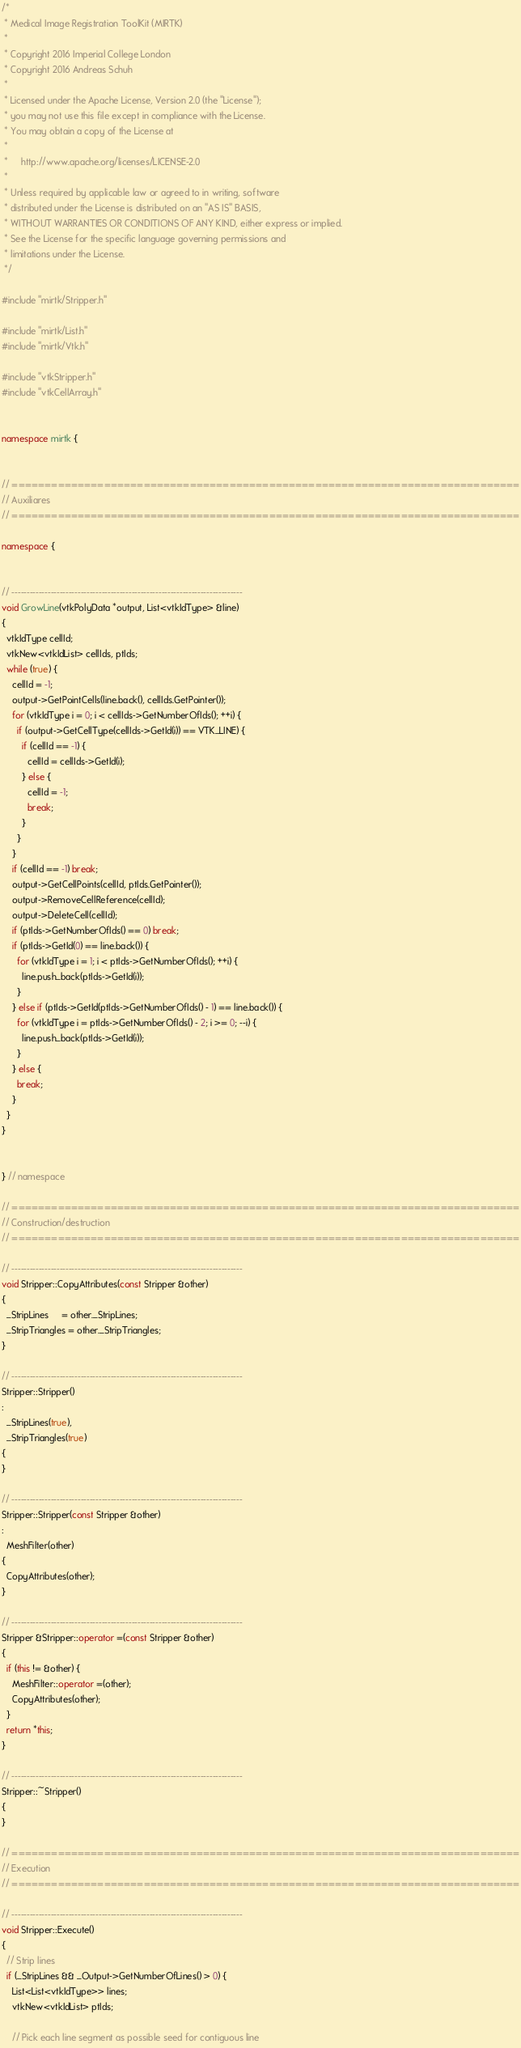<code> <loc_0><loc_0><loc_500><loc_500><_C++_>/*
 * Medical Image Registration ToolKit (MIRTK)
 *
 * Copyright 2016 Imperial College London
 * Copyright 2016 Andreas Schuh
 *
 * Licensed under the Apache License, Version 2.0 (the "License");
 * you may not use this file except in compliance with the License.
 * You may obtain a copy of the License at
 *
 *     http://www.apache.org/licenses/LICENSE-2.0
 *
 * Unless required by applicable law or agreed to in writing, software
 * distributed under the License is distributed on an "AS IS" BASIS,
 * WITHOUT WARRANTIES OR CONDITIONS OF ANY KIND, either express or implied.
 * See the License for the specific language governing permissions and
 * limitations under the License.
 */

#include "mirtk/Stripper.h"

#include "mirtk/List.h"
#include "mirtk/Vtk.h"

#include "vtkStripper.h"
#include "vtkCellArray.h"


namespace mirtk {


// =============================================================================
// Auxiliares
// =============================================================================

namespace {


// -----------------------------------------------------------------------------
void GrowLine(vtkPolyData *output, List<vtkIdType> &line)
{
  vtkIdType cellId;
  vtkNew<vtkIdList> cellIds, ptIds;
  while (true) {
    cellId = -1;
    output->GetPointCells(line.back(), cellIds.GetPointer());
    for (vtkIdType i = 0; i < cellIds->GetNumberOfIds(); ++i) {
      if (output->GetCellType(cellIds->GetId(i)) == VTK_LINE) {
        if (cellId == -1) {
          cellId = cellIds->GetId(i);
        } else {
          cellId = -1;
          break;
        }
      }
    }
    if (cellId == -1) break;
    output->GetCellPoints(cellId, ptIds.GetPointer());
    output->RemoveCellReference(cellId);
    output->DeleteCell(cellId);
    if (ptIds->GetNumberOfIds() == 0) break;
    if (ptIds->GetId(0) == line.back()) {
      for (vtkIdType i = 1; i < ptIds->GetNumberOfIds(); ++i) {
        line.push_back(ptIds->GetId(i));
      }
    } else if (ptIds->GetId(ptIds->GetNumberOfIds() - 1) == line.back()) {
      for (vtkIdType i = ptIds->GetNumberOfIds() - 2; i >= 0; --i) {
        line.push_back(ptIds->GetId(i));
      }
    } else {
      break;
    }
  }
}


} // namespace

// =============================================================================
// Construction/destruction
// =============================================================================

// -----------------------------------------------------------------------------
void Stripper::CopyAttributes(const Stripper &other)
{
  _StripLines     = other._StripLines;
  _StripTriangles = other._StripTriangles;
}

// -----------------------------------------------------------------------------
Stripper::Stripper()
:
  _StripLines(true),
  _StripTriangles(true)
{
}

// -----------------------------------------------------------------------------
Stripper::Stripper(const Stripper &other)
:
  MeshFilter(other)
{
  CopyAttributes(other);
}

// -----------------------------------------------------------------------------
Stripper &Stripper::operator =(const Stripper &other)
{
  if (this != &other) {
    MeshFilter::operator =(other);
    CopyAttributes(other);
  }
  return *this;
}

// -----------------------------------------------------------------------------
Stripper::~Stripper()
{
}

// =============================================================================
// Execution
// =============================================================================

// -----------------------------------------------------------------------------
void Stripper::Execute()
{
  // Strip lines
  if (_StripLines && _Output->GetNumberOfLines() > 0) {
    List<List<vtkIdType>> lines;
    vtkNew<vtkIdList> ptIds;

    // Pick each line segment as possible seed for contiguous line</code> 